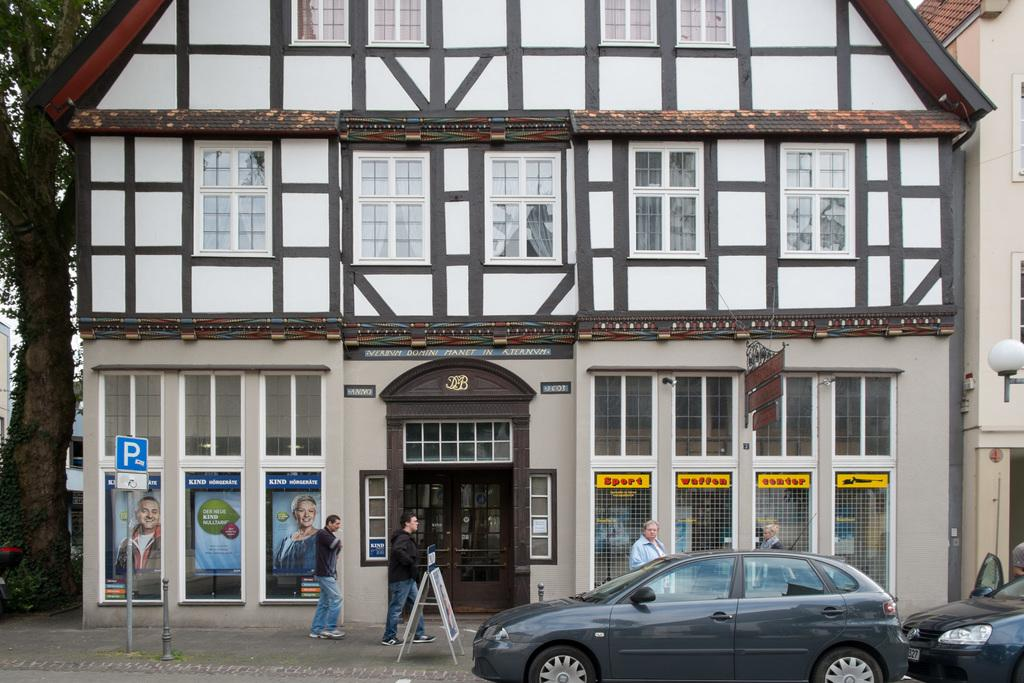What can be seen in the foreground of the image? In the foreground of the image, there are people, cars, poles, and a footpath. What type of structures are visible in the middle of the image? There are buildings in the middle of the image. What other elements can be seen on the left side of the image? On the left side of the image, there are trees and buildings. How many legs are visible on the tent in the image? There is no tent present in the image. What type of cable can be seen connecting the cars in the image? There is no cable connecting the cars in the image. 